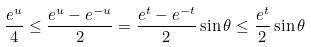Convert formula to latex. <formula><loc_0><loc_0><loc_500><loc_500>\frac { e ^ { u } } { 4 } \leq \frac { e ^ { u } - e ^ { - u } } { 2 } = \frac { e ^ { t } - e ^ { - t } } { 2 } \sin \theta \leq \frac { e ^ { t } } { 2 } \sin \theta</formula> 